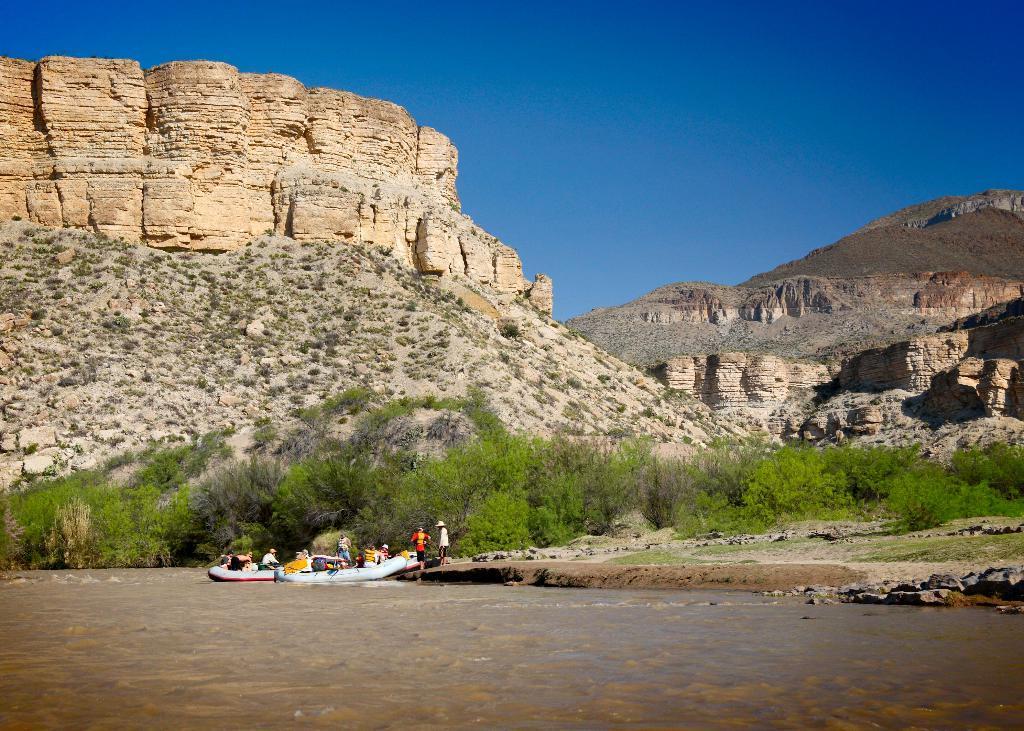Can you describe this image briefly? In this picture I can see there is a mountain here and there are trees and there are some people here in the boats and the sky is clear. 